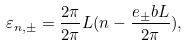Convert formula to latex. <formula><loc_0><loc_0><loc_500><loc_500>\varepsilon _ { n , { \pm } } = \frac { 2 \pi } { 2 \pi } { L } ( n { } - \frac { e _ { \pm } b L } { 2 \pi } ) ,</formula> 